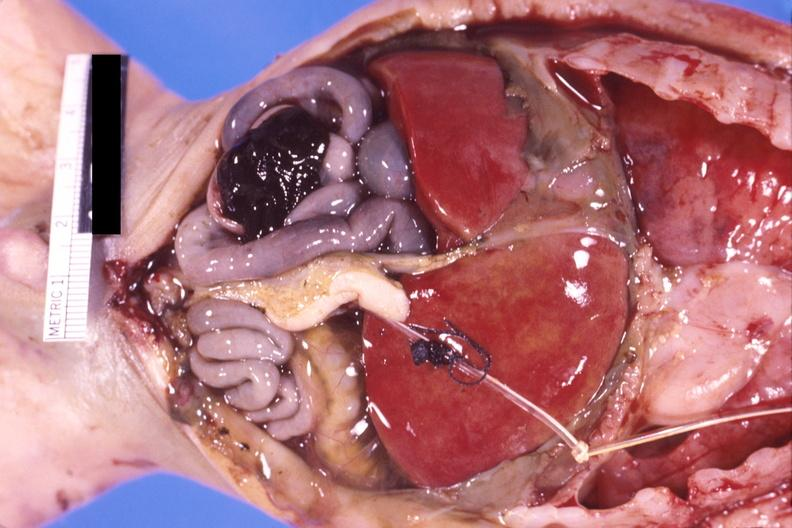what does this image show?
Answer the question using a single word or phrase. Pneumotosis intestinalis with rupture and hemorrhage in a patient with hyaline membrane disease 